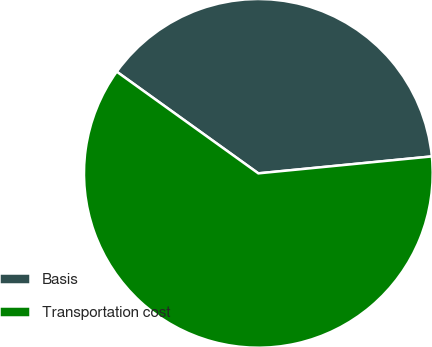Convert chart. <chart><loc_0><loc_0><loc_500><loc_500><pie_chart><fcel>Basis<fcel>Transportation cost<nl><fcel>38.54%<fcel>61.46%<nl></chart> 